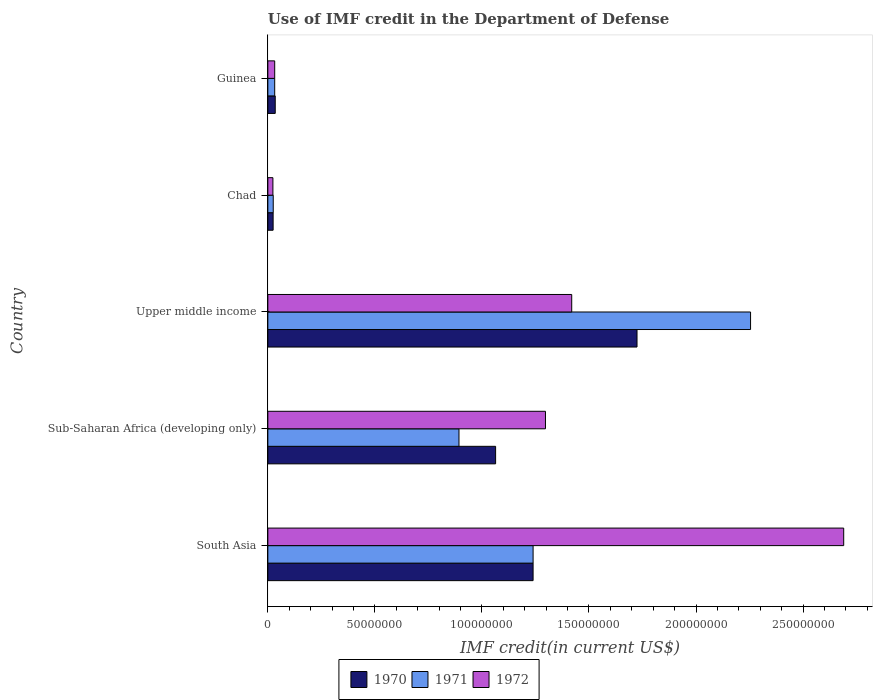How many different coloured bars are there?
Give a very brief answer. 3. Are the number of bars on each tick of the Y-axis equal?
Offer a very short reply. Yes. What is the label of the 3rd group of bars from the top?
Make the answer very short. Upper middle income. In how many cases, is the number of bars for a given country not equal to the number of legend labels?
Ensure brevity in your answer.  0. What is the IMF credit in the Department of Defense in 1970 in Chad?
Ensure brevity in your answer.  2.47e+06. Across all countries, what is the maximum IMF credit in the Department of Defense in 1972?
Your answer should be compact. 2.69e+08. Across all countries, what is the minimum IMF credit in the Department of Defense in 1970?
Offer a terse response. 2.47e+06. In which country was the IMF credit in the Department of Defense in 1970 maximum?
Keep it short and to the point. Upper middle income. In which country was the IMF credit in the Department of Defense in 1972 minimum?
Your answer should be compact. Chad. What is the total IMF credit in the Department of Defense in 1972 in the graph?
Keep it short and to the point. 5.46e+08. What is the difference between the IMF credit in the Department of Defense in 1970 in South Asia and that in Sub-Saharan Africa (developing only)?
Your answer should be compact. 1.75e+07. What is the difference between the IMF credit in the Department of Defense in 1971 in Chad and the IMF credit in the Department of Defense in 1970 in Guinea?
Ensure brevity in your answer.  -9.31e+05. What is the average IMF credit in the Department of Defense in 1972 per country?
Your answer should be compact. 1.09e+08. What is the difference between the IMF credit in the Department of Defense in 1970 and IMF credit in the Department of Defense in 1972 in Guinea?
Provide a short and direct response. 2.47e+05. In how many countries, is the IMF credit in the Department of Defense in 1970 greater than 20000000 US$?
Your response must be concise. 3. What is the ratio of the IMF credit in the Department of Defense in 1972 in Chad to that in Guinea?
Make the answer very short. 0.74. Is the IMF credit in the Department of Defense in 1970 in Chad less than that in Guinea?
Ensure brevity in your answer.  Yes. Is the difference between the IMF credit in the Department of Defense in 1970 in South Asia and Upper middle income greater than the difference between the IMF credit in the Department of Defense in 1972 in South Asia and Upper middle income?
Keep it short and to the point. No. What is the difference between the highest and the second highest IMF credit in the Department of Defense in 1971?
Provide a succinct answer. 1.02e+08. What is the difference between the highest and the lowest IMF credit in the Department of Defense in 1970?
Your answer should be compact. 1.70e+08. Are all the bars in the graph horizontal?
Ensure brevity in your answer.  Yes. What is the difference between two consecutive major ticks on the X-axis?
Provide a short and direct response. 5.00e+07. Are the values on the major ticks of X-axis written in scientific E-notation?
Your answer should be compact. No. Does the graph contain any zero values?
Your answer should be very brief. No. What is the title of the graph?
Provide a short and direct response. Use of IMF credit in the Department of Defense. What is the label or title of the X-axis?
Keep it short and to the point. IMF credit(in current US$). What is the label or title of the Y-axis?
Offer a terse response. Country. What is the IMF credit(in current US$) in 1970 in South Asia?
Your answer should be compact. 1.24e+08. What is the IMF credit(in current US$) in 1971 in South Asia?
Provide a short and direct response. 1.24e+08. What is the IMF credit(in current US$) in 1972 in South Asia?
Provide a short and direct response. 2.69e+08. What is the IMF credit(in current US$) in 1970 in Sub-Saharan Africa (developing only)?
Your response must be concise. 1.06e+08. What is the IMF credit(in current US$) in 1971 in Sub-Saharan Africa (developing only)?
Provide a succinct answer. 8.93e+07. What is the IMF credit(in current US$) in 1972 in Sub-Saharan Africa (developing only)?
Provide a short and direct response. 1.30e+08. What is the IMF credit(in current US$) in 1970 in Upper middle income?
Provide a short and direct response. 1.72e+08. What is the IMF credit(in current US$) of 1971 in Upper middle income?
Your answer should be compact. 2.25e+08. What is the IMF credit(in current US$) in 1972 in Upper middle income?
Provide a short and direct response. 1.42e+08. What is the IMF credit(in current US$) of 1970 in Chad?
Your response must be concise. 2.47e+06. What is the IMF credit(in current US$) in 1971 in Chad?
Ensure brevity in your answer.  2.52e+06. What is the IMF credit(in current US$) of 1972 in Chad?
Provide a succinct answer. 2.37e+06. What is the IMF credit(in current US$) of 1970 in Guinea?
Provide a succinct answer. 3.45e+06. What is the IMF credit(in current US$) in 1971 in Guinea?
Give a very brief answer. 3.20e+06. What is the IMF credit(in current US$) of 1972 in Guinea?
Keep it short and to the point. 3.20e+06. Across all countries, what is the maximum IMF credit(in current US$) of 1970?
Your response must be concise. 1.72e+08. Across all countries, what is the maximum IMF credit(in current US$) in 1971?
Your answer should be compact. 2.25e+08. Across all countries, what is the maximum IMF credit(in current US$) of 1972?
Make the answer very short. 2.69e+08. Across all countries, what is the minimum IMF credit(in current US$) in 1970?
Give a very brief answer. 2.47e+06. Across all countries, what is the minimum IMF credit(in current US$) of 1971?
Offer a very short reply. 2.52e+06. Across all countries, what is the minimum IMF credit(in current US$) of 1972?
Your answer should be very brief. 2.37e+06. What is the total IMF credit(in current US$) in 1970 in the graph?
Make the answer very short. 4.09e+08. What is the total IMF credit(in current US$) in 1971 in the graph?
Make the answer very short. 4.44e+08. What is the total IMF credit(in current US$) of 1972 in the graph?
Keep it short and to the point. 5.46e+08. What is the difference between the IMF credit(in current US$) in 1970 in South Asia and that in Sub-Saharan Africa (developing only)?
Make the answer very short. 1.75e+07. What is the difference between the IMF credit(in current US$) in 1971 in South Asia and that in Sub-Saharan Africa (developing only)?
Your response must be concise. 3.46e+07. What is the difference between the IMF credit(in current US$) in 1972 in South Asia and that in Sub-Saharan Africa (developing only)?
Your answer should be compact. 1.39e+08. What is the difference between the IMF credit(in current US$) of 1970 in South Asia and that in Upper middle income?
Make the answer very short. -4.86e+07. What is the difference between the IMF credit(in current US$) of 1971 in South Asia and that in Upper middle income?
Provide a succinct answer. -1.02e+08. What is the difference between the IMF credit(in current US$) in 1972 in South Asia and that in Upper middle income?
Offer a terse response. 1.27e+08. What is the difference between the IMF credit(in current US$) in 1970 in South Asia and that in Chad?
Your response must be concise. 1.21e+08. What is the difference between the IMF credit(in current US$) in 1971 in South Asia and that in Chad?
Your answer should be very brief. 1.21e+08. What is the difference between the IMF credit(in current US$) of 1972 in South Asia and that in Chad?
Your answer should be very brief. 2.67e+08. What is the difference between the IMF credit(in current US$) in 1970 in South Asia and that in Guinea?
Offer a very short reply. 1.20e+08. What is the difference between the IMF credit(in current US$) in 1971 in South Asia and that in Guinea?
Offer a terse response. 1.21e+08. What is the difference between the IMF credit(in current US$) of 1972 in South Asia and that in Guinea?
Provide a succinct answer. 2.66e+08. What is the difference between the IMF credit(in current US$) of 1970 in Sub-Saharan Africa (developing only) and that in Upper middle income?
Your answer should be very brief. -6.61e+07. What is the difference between the IMF credit(in current US$) in 1971 in Sub-Saharan Africa (developing only) and that in Upper middle income?
Offer a terse response. -1.36e+08. What is the difference between the IMF credit(in current US$) of 1972 in Sub-Saharan Africa (developing only) and that in Upper middle income?
Ensure brevity in your answer.  -1.23e+07. What is the difference between the IMF credit(in current US$) of 1970 in Sub-Saharan Africa (developing only) and that in Chad?
Ensure brevity in your answer.  1.04e+08. What is the difference between the IMF credit(in current US$) in 1971 in Sub-Saharan Africa (developing only) and that in Chad?
Provide a short and direct response. 8.68e+07. What is the difference between the IMF credit(in current US$) in 1972 in Sub-Saharan Africa (developing only) and that in Chad?
Offer a terse response. 1.27e+08. What is the difference between the IMF credit(in current US$) in 1970 in Sub-Saharan Africa (developing only) and that in Guinea?
Keep it short and to the point. 1.03e+08. What is the difference between the IMF credit(in current US$) in 1971 in Sub-Saharan Africa (developing only) and that in Guinea?
Offer a terse response. 8.61e+07. What is the difference between the IMF credit(in current US$) in 1972 in Sub-Saharan Africa (developing only) and that in Guinea?
Your response must be concise. 1.26e+08. What is the difference between the IMF credit(in current US$) of 1970 in Upper middle income and that in Chad?
Give a very brief answer. 1.70e+08. What is the difference between the IMF credit(in current US$) of 1971 in Upper middle income and that in Chad?
Offer a terse response. 2.23e+08. What is the difference between the IMF credit(in current US$) in 1972 in Upper middle income and that in Chad?
Your response must be concise. 1.40e+08. What is the difference between the IMF credit(in current US$) in 1970 in Upper middle income and that in Guinea?
Your answer should be very brief. 1.69e+08. What is the difference between the IMF credit(in current US$) of 1971 in Upper middle income and that in Guinea?
Your response must be concise. 2.22e+08. What is the difference between the IMF credit(in current US$) in 1972 in Upper middle income and that in Guinea?
Your answer should be very brief. 1.39e+08. What is the difference between the IMF credit(in current US$) of 1970 in Chad and that in Guinea?
Provide a succinct answer. -9.80e+05. What is the difference between the IMF credit(in current US$) in 1971 in Chad and that in Guinea?
Make the answer very short. -6.84e+05. What is the difference between the IMF credit(in current US$) of 1972 in Chad and that in Guinea?
Make the answer very short. -8.36e+05. What is the difference between the IMF credit(in current US$) of 1970 in South Asia and the IMF credit(in current US$) of 1971 in Sub-Saharan Africa (developing only)?
Offer a very short reply. 3.46e+07. What is the difference between the IMF credit(in current US$) in 1970 in South Asia and the IMF credit(in current US$) in 1972 in Sub-Saharan Africa (developing only)?
Your answer should be compact. -5.79e+06. What is the difference between the IMF credit(in current US$) in 1971 in South Asia and the IMF credit(in current US$) in 1972 in Sub-Saharan Africa (developing only)?
Your answer should be very brief. -5.79e+06. What is the difference between the IMF credit(in current US$) in 1970 in South Asia and the IMF credit(in current US$) in 1971 in Upper middle income?
Keep it short and to the point. -1.02e+08. What is the difference between the IMF credit(in current US$) in 1970 in South Asia and the IMF credit(in current US$) in 1972 in Upper middle income?
Your answer should be very brief. -1.80e+07. What is the difference between the IMF credit(in current US$) in 1971 in South Asia and the IMF credit(in current US$) in 1972 in Upper middle income?
Your answer should be compact. -1.80e+07. What is the difference between the IMF credit(in current US$) in 1970 in South Asia and the IMF credit(in current US$) in 1971 in Chad?
Your answer should be very brief. 1.21e+08. What is the difference between the IMF credit(in current US$) in 1970 in South Asia and the IMF credit(in current US$) in 1972 in Chad?
Your answer should be very brief. 1.22e+08. What is the difference between the IMF credit(in current US$) of 1971 in South Asia and the IMF credit(in current US$) of 1972 in Chad?
Ensure brevity in your answer.  1.22e+08. What is the difference between the IMF credit(in current US$) in 1970 in South Asia and the IMF credit(in current US$) in 1971 in Guinea?
Ensure brevity in your answer.  1.21e+08. What is the difference between the IMF credit(in current US$) of 1970 in South Asia and the IMF credit(in current US$) of 1972 in Guinea?
Make the answer very short. 1.21e+08. What is the difference between the IMF credit(in current US$) of 1971 in South Asia and the IMF credit(in current US$) of 1972 in Guinea?
Provide a short and direct response. 1.21e+08. What is the difference between the IMF credit(in current US$) of 1970 in Sub-Saharan Africa (developing only) and the IMF credit(in current US$) of 1971 in Upper middle income?
Offer a very short reply. -1.19e+08. What is the difference between the IMF credit(in current US$) of 1970 in Sub-Saharan Africa (developing only) and the IMF credit(in current US$) of 1972 in Upper middle income?
Ensure brevity in your answer.  -3.56e+07. What is the difference between the IMF credit(in current US$) of 1971 in Sub-Saharan Africa (developing only) and the IMF credit(in current US$) of 1972 in Upper middle income?
Ensure brevity in your answer.  -5.27e+07. What is the difference between the IMF credit(in current US$) in 1970 in Sub-Saharan Africa (developing only) and the IMF credit(in current US$) in 1971 in Chad?
Ensure brevity in your answer.  1.04e+08. What is the difference between the IMF credit(in current US$) of 1970 in Sub-Saharan Africa (developing only) and the IMF credit(in current US$) of 1972 in Chad?
Your answer should be very brief. 1.04e+08. What is the difference between the IMF credit(in current US$) of 1971 in Sub-Saharan Africa (developing only) and the IMF credit(in current US$) of 1972 in Chad?
Offer a terse response. 8.69e+07. What is the difference between the IMF credit(in current US$) of 1970 in Sub-Saharan Africa (developing only) and the IMF credit(in current US$) of 1971 in Guinea?
Offer a terse response. 1.03e+08. What is the difference between the IMF credit(in current US$) in 1970 in Sub-Saharan Africa (developing only) and the IMF credit(in current US$) in 1972 in Guinea?
Give a very brief answer. 1.03e+08. What is the difference between the IMF credit(in current US$) of 1971 in Sub-Saharan Africa (developing only) and the IMF credit(in current US$) of 1972 in Guinea?
Make the answer very short. 8.61e+07. What is the difference between the IMF credit(in current US$) of 1970 in Upper middle income and the IMF credit(in current US$) of 1971 in Chad?
Provide a succinct answer. 1.70e+08. What is the difference between the IMF credit(in current US$) in 1970 in Upper middle income and the IMF credit(in current US$) in 1972 in Chad?
Your answer should be very brief. 1.70e+08. What is the difference between the IMF credit(in current US$) in 1971 in Upper middle income and the IMF credit(in current US$) in 1972 in Chad?
Offer a very short reply. 2.23e+08. What is the difference between the IMF credit(in current US$) of 1970 in Upper middle income and the IMF credit(in current US$) of 1971 in Guinea?
Your answer should be compact. 1.69e+08. What is the difference between the IMF credit(in current US$) in 1970 in Upper middle income and the IMF credit(in current US$) in 1972 in Guinea?
Your answer should be compact. 1.69e+08. What is the difference between the IMF credit(in current US$) in 1971 in Upper middle income and the IMF credit(in current US$) in 1972 in Guinea?
Offer a terse response. 2.22e+08. What is the difference between the IMF credit(in current US$) in 1970 in Chad and the IMF credit(in current US$) in 1971 in Guinea?
Your answer should be very brief. -7.33e+05. What is the difference between the IMF credit(in current US$) of 1970 in Chad and the IMF credit(in current US$) of 1972 in Guinea?
Ensure brevity in your answer.  -7.33e+05. What is the difference between the IMF credit(in current US$) in 1971 in Chad and the IMF credit(in current US$) in 1972 in Guinea?
Ensure brevity in your answer.  -6.84e+05. What is the average IMF credit(in current US$) in 1970 per country?
Ensure brevity in your answer.  8.17e+07. What is the average IMF credit(in current US$) in 1971 per country?
Offer a very short reply. 8.89e+07. What is the average IMF credit(in current US$) in 1972 per country?
Ensure brevity in your answer.  1.09e+08. What is the difference between the IMF credit(in current US$) in 1970 and IMF credit(in current US$) in 1972 in South Asia?
Offer a very short reply. -1.45e+08. What is the difference between the IMF credit(in current US$) of 1971 and IMF credit(in current US$) of 1972 in South Asia?
Offer a very short reply. -1.45e+08. What is the difference between the IMF credit(in current US$) in 1970 and IMF credit(in current US$) in 1971 in Sub-Saharan Africa (developing only)?
Provide a short and direct response. 1.71e+07. What is the difference between the IMF credit(in current US$) in 1970 and IMF credit(in current US$) in 1972 in Sub-Saharan Africa (developing only)?
Keep it short and to the point. -2.33e+07. What is the difference between the IMF credit(in current US$) in 1971 and IMF credit(in current US$) in 1972 in Sub-Saharan Africa (developing only)?
Your response must be concise. -4.04e+07. What is the difference between the IMF credit(in current US$) of 1970 and IMF credit(in current US$) of 1971 in Upper middle income?
Make the answer very short. -5.30e+07. What is the difference between the IMF credit(in current US$) of 1970 and IMF credit(in current US$) of 1972 in Upper middle income?
Your answer should be compact. 3.05e+07. What is the difference between the IMF credit(in current US$) of 1971 and IMF credit(in current US$) of 1972 in Upper middle income?
Give a very brief answer. 8.35e+07. What is the difference between the IMF credit(in current US$) of 1970 and IMF credit(in current US$) of 1971 in Chad?
Your response must be concise. -4.90e+04. What is the difference between the IMF credit(in current US$) in 1970 and IMF credit(in current US$) in 1972 in Chad?
Make the answer very short. 1.03e+05. What is the difference between the IMF credit(in current US$) of 1971 and IMF credit(in current US$) of 1972 in Chad?
Your answer should be compact. 1.52e+05. What is the difference between the IMF credit(in current US$) of 1970 and IMF credit(in current US$) of 1971 in Guinea?
Give a very brief answer. 2.47e+05. What is the difference between the IMF credit(in current US$) of 1970 and IMF credit(in current US$) of 1972 in Guinea?
Your response must be concise. 2.47e+05. What is the ratio of the IMF credit(in current US$) of 1970 in South Asia to that in Sub-Saharan Africa (developing only)?
Give a very brief answer. 1.16. What is the ratio of the IMF credit(in current US$) of 1971 in South Asia to that in Sub-Saharan Africa (developing only)?
Give a very brief answer. 1.39. What is the ratio of the IMF credit(in current US$) of 1972 in South Asia to that in Sub-Saharan Africa (developing only)?
Your answer should be very brief. 2.07. What is the ratio of the IMF credit(in current US$) of 1970 in South Asia to that in Upper middle income?
Provide a succinct answer. 0.72. What is the ratio of the IMF credit(in current US$) of 1971 in South Asia to that in Upper middle income?
Ensure brevity in your answer.  0.55. What is the ratio of the IMF credit(in current US$) in 1972 in South Asia to that in Upper middle income?
Make the answer very short. 1.9. What is the ratio of the IMF credit(in current US$) in 1970 in South Asia to that in Chad?
Your answer should be very brief. 50.16. What is the ratio of the IMF credit(in current US$) of 1971 in South Asia to that in Chad?
Your answer should be very brief. 49.19. What is the ratio of the IMF credit(in current US$) in 1972 in South Asia to that in Chad?
Your answer should be compact. 113.64. What is the ratio of the IMF credit(in current US$) of 1970 in South Asia to that in Guinea?
Make the answer very short. 35.91. What is the ratio of the IMF credit(in current US$) of 1971 in South Asia to that in Guinea?
Offer a very short reply. 38.68. What is the ratio of the IMF credit(in current US$) of 1972 in South Asia to that in Guinea?
Give a very brief answer. 83.98. What is the ratio of the IMF credit(in current US$) in 1970 in Sub-Saharan Africa (developing only) to that in Upper middle income?
Keep it short and to the point. 0.62. What is the ratio of the IMF credit(in current US$) of 1971 in Sub-Saharan Africa (developing only) to that in Upper middle income?
Give a very brief answer. 0.4. What is the ratio of the IMF credit(in current US$) of 1972 in Sub-Saharan Africa (developing only) to that in Upper middle income?
Provide a short and direct response. 0.91. What is the ratio of the IMF credit(in current US$) of 1970 in Sub-Saharan Africa (developing only) to that in Chad?
Your answer should be very brief. 43.07. What is the ratio of the IMF credit(in current US$) in 1971 in Sub-Saharan Africa (developing only) to that in Chad?
Keep it short and to the point. 35.45. What is the ratio of the IMF credit(in current US$) of 1972 in Sub-Saharan Africa (developing only) to that in Chad?
Give a very brief answer. 54.79. What is the ratio of the IMF credit(in current US$) in 1970 in Sub-Saharan Africa (developing only) to that in Guinea?
Your answer should be compact. 30.84. What is the ratio of the IMF credit(in current US$) of 1971 in Sub-Saharan Africa (developing only) to that in Guinea?
Offer a terse response. 27.88. What is the ratio of the IMF credit(in current US$) in 1972 in Sub-Saharan Africa (developing only) to that in Guinea?
Make the answer very short. 40.49. What is the ratio of the IMF credit(in current US$) in 1970 in Upper middle income to that in Chad?
Your response must be concise. 69.82. What is the ratio of the IMF credit(in current US$) of 1971 in Upper middle income to that in Chad?
Your answer should be very brief. 89.51. What is the ratio of the IMF credit(in current US$) in 1972 in Upper middle income to that in Chad?
Make the answer very short. 59.97. What is the ratio of the IMF credit(in current US$) of 1970 in Upper middle income to that in Guinea?
Offer a terse response. 49.99. What is the ratio of the IMF credit(in current US$) in 1971 in Upper middle income to that in Guinea?
Your answer should be very brief. 70.4. What is the ratio of the IMF credit(in current US$) in 1972 in Upper middle income to that in Guinea?
Your answer should be very brief. 44.32. What is the ratio of the IMF credit(in current US$) of 1970 in Chad to that in Guinea?
Offer a very short reply. 0.72. What is the ratio of the IMF credit(in current US$) of 1971 in Chad to that in Guinea?
Your answer should be very brief. 0.79. What is the ratio of the IMF credit(in current US$) of 1972 in Chad to that in Guinea?
Your response must be concise. 0.74. What is the difference between the highest and the second highest IMF credit(in current US$) of 1970?
Provide a short and direct response. 4.86e+07. What is the difference between the highest and the second highest IMF credit(in current US$) in 1971?
Offer a very short reply. 1.02e+08. What is the difference between the highest and the second highest IMF credit(in current US$) in 1972?
Your answer should be very brief. 1.27e+08. What is the difference between the highest and the lowest IMF credit(in current US$) in 1970?
Offer a terse response. 1.70e+08. What is the difference between the highest and the lowest IMF credit(in current US$) in 1971?
Your answer should be very brief. 2.23e+08. What is the difference between the highest and the lowest IMF credit(in current US$) in 1972?
Make the answer very short. 2.67e+08. 